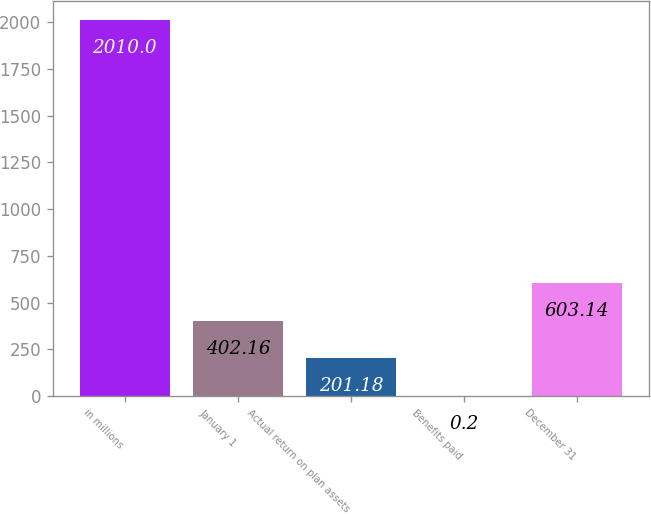Convert chart. <chart><loc_0><loc_0><loc_500><loc_500><bar_chart><fcel>in millions<fcel>January 1<fcel>Actual return on plan assets<fcel>Benefits paid<fcel>December 31<nl><fcel>2010<fcel>402.16<fcel>201.18<fcel>0.2<fcel>603.14<nl></chart> 